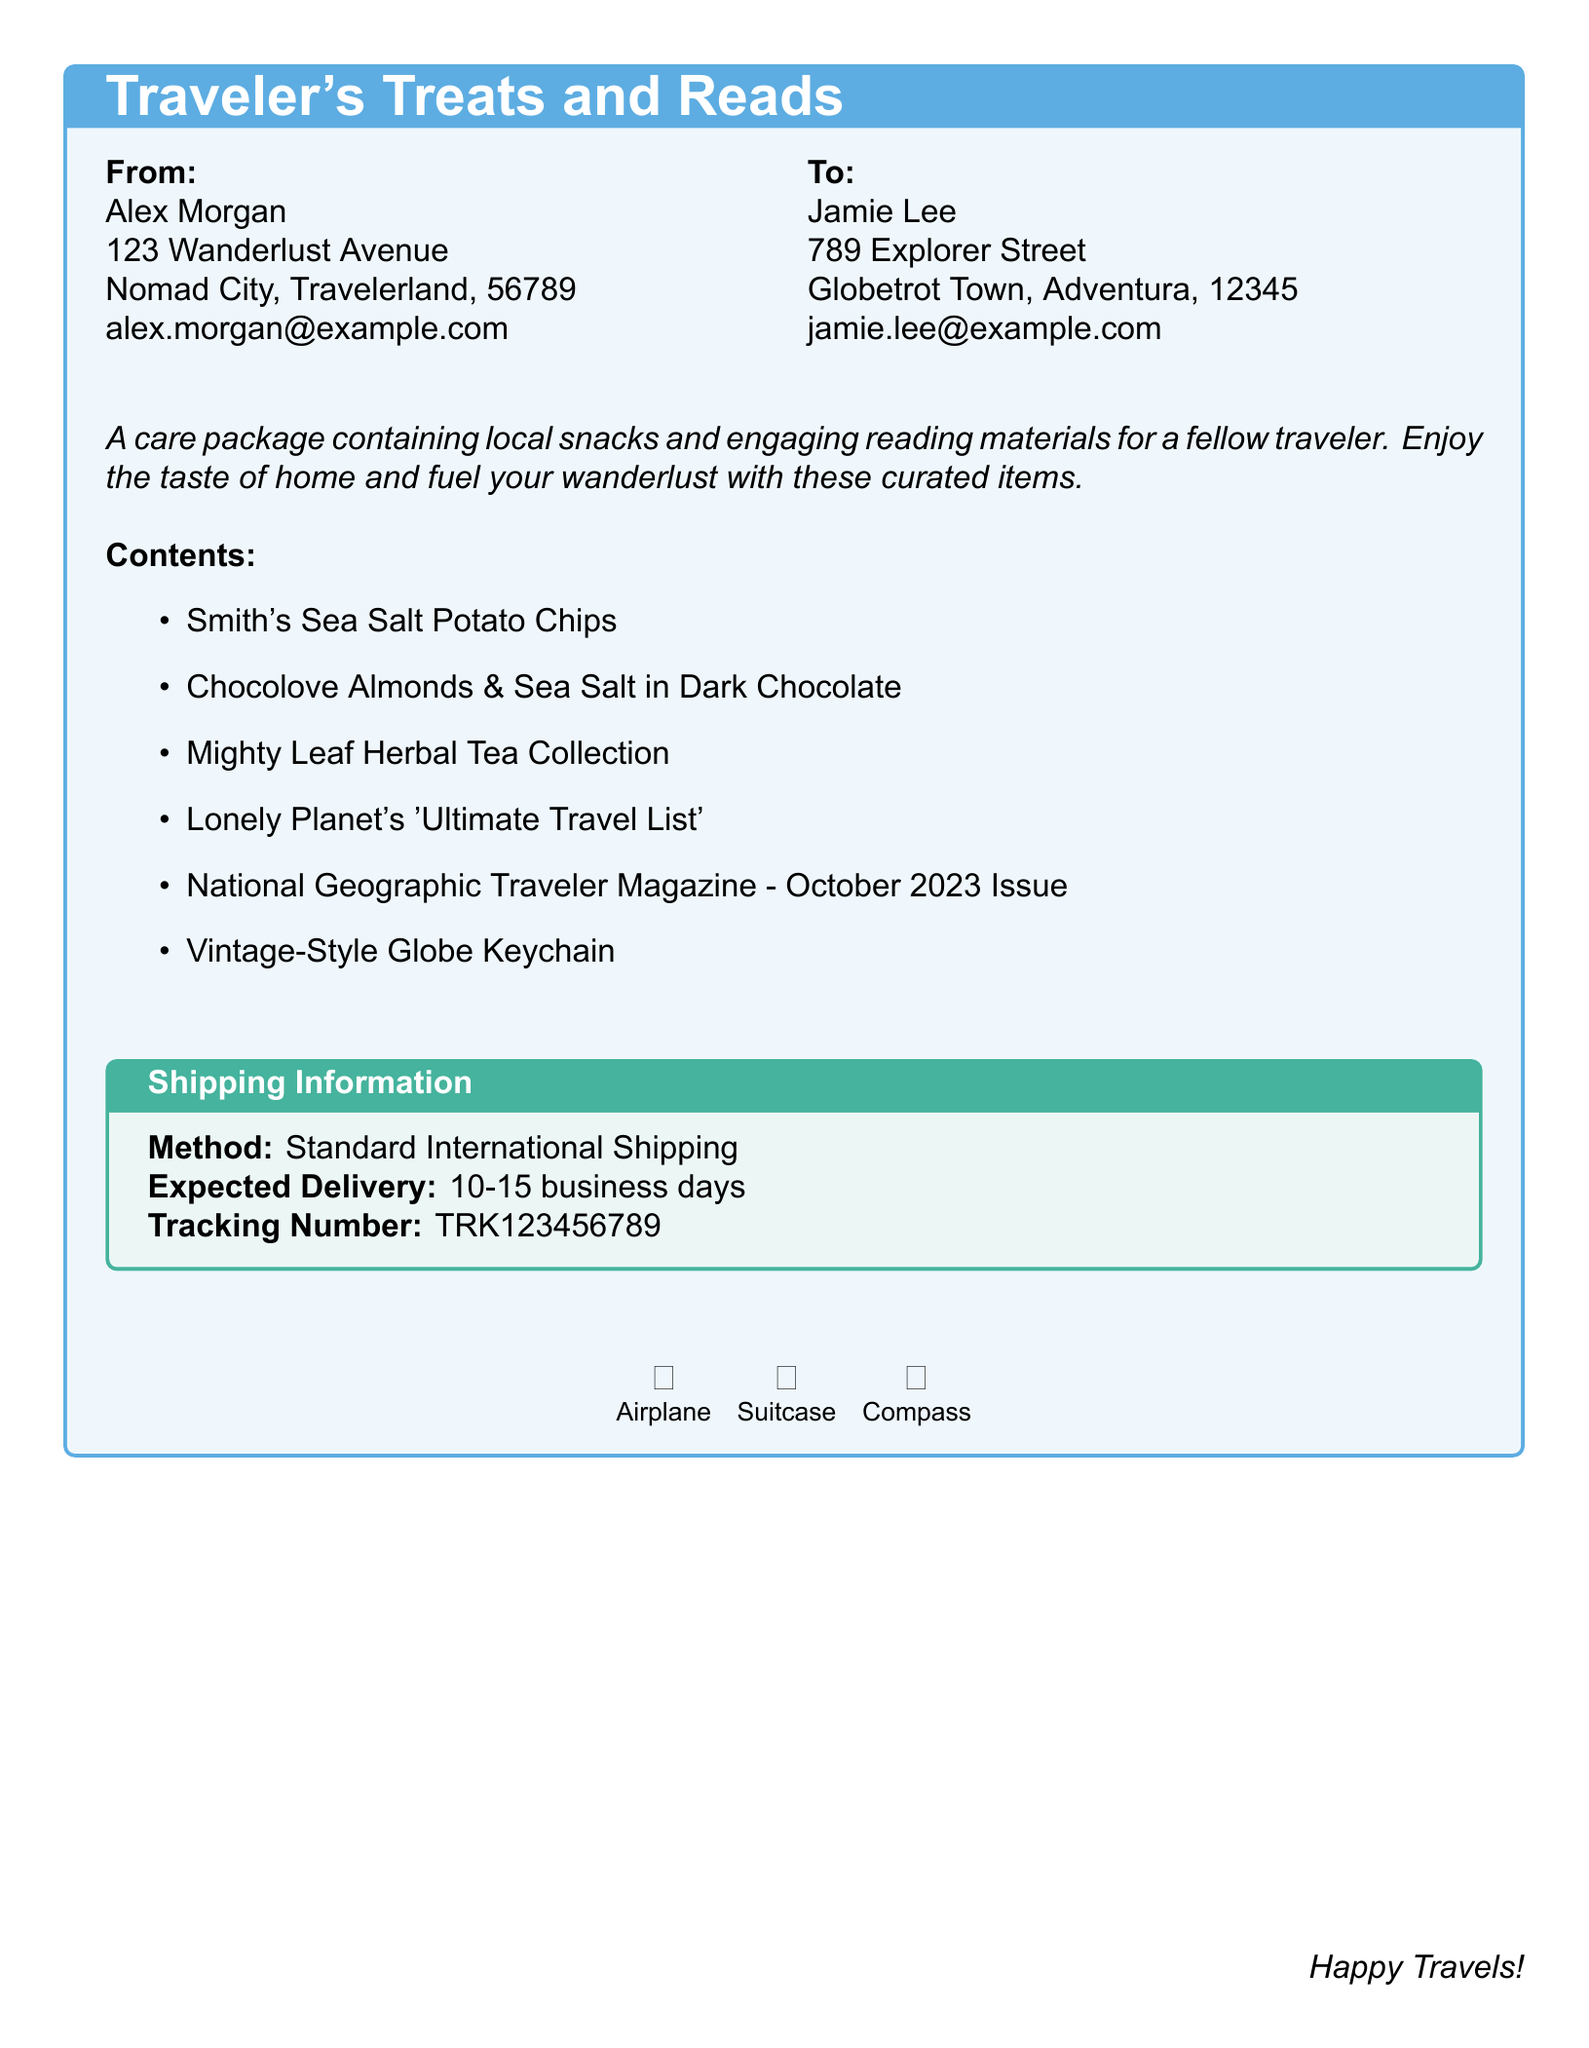What is the sender's name? The sender's name is found in the "From" section of the document, which reads "Alex Morgan."
Answer: Alex Morgan What is the recipient's email? The recipient's email is located in the "To" section of the document, specifically "jamie.lee@example.com."
Answer: jamie.lee@example.com What is the expected delivery time? The expected delivery time is stated under the shipping information section, which shows "10-15 business days."
Answer: 10-15 business days Which magazine is included in the package? The magazine included in the package is specified in the contents list, where it states "National Geographic Traveler Magazine - October 2023 Issue."
Answer: National Geographic Traveler Magazine - October 2023 Issue What item is the keychain styled after? The keychain's description is included in the contents section that mentions a "Vintage-Style Globe Keychain."
Answer: Vintage-Style Globe What categories do the contents belong to? The contents consist of both snacks and reading materials as described in the introductory text.
Answer: Snacks and reading materials What is the tracking number for the shipment? The tracking number is detailed in the shipping information box, appearing as "TRK123456789."
Answer: TRK123456789 What is the shipping method used? The shipping method is explicitly mentioned in the document in the shipping information section as "Standard International Shipping."
Answer: Standard International Shipping 